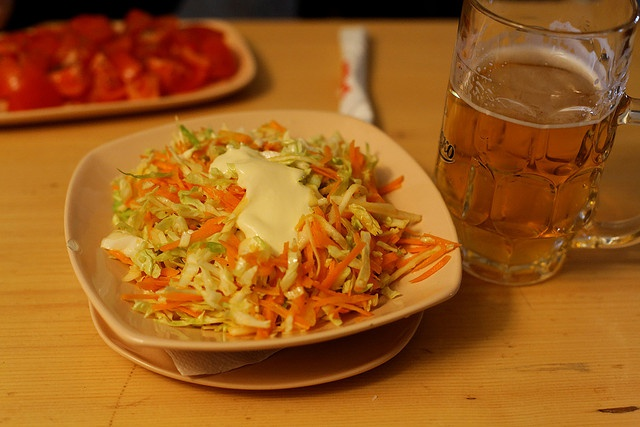Describe the objects in this image and their specific colors. I can see dining table in maroon and orange tones, cup in maroon and brown tones, bowl in maroon and orange tones, carrot in maroon, red, and orange tones, and carrot in maroon, red, brown, and orange tones in this image. 